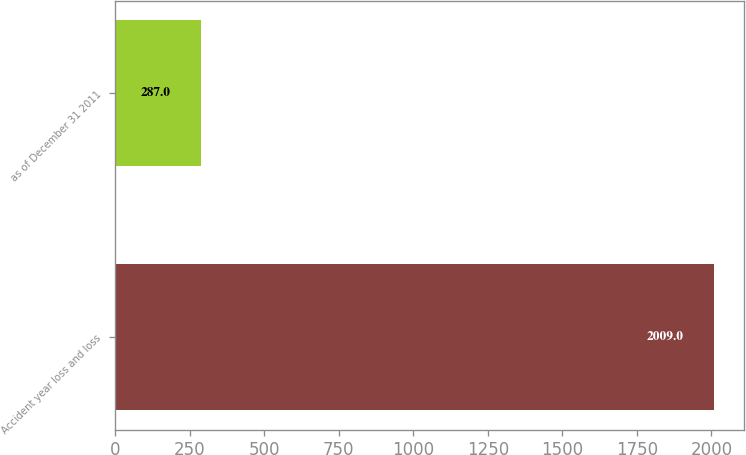<chart> <loc_0><loc_0><loc_500><loc_500><bar_chart><fcel>Accident year loss and loss<fcel>as of December 31 2011<nl><fcel>2009<fcel>287<nl></chart> 